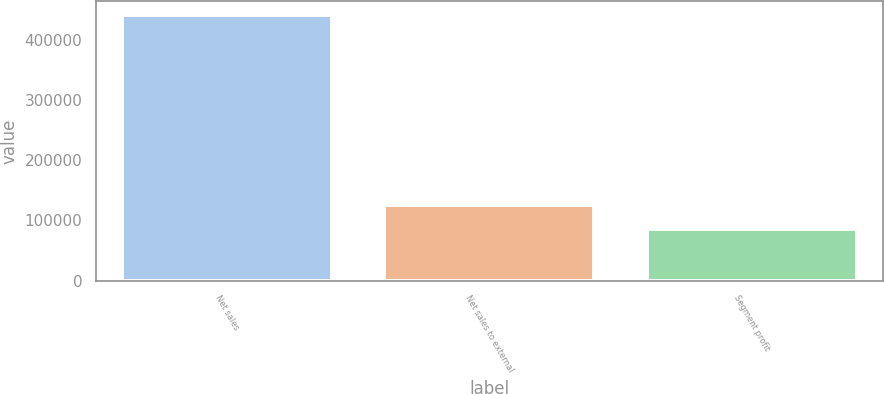Convert chart to OTSL. <chart><loc_0><loc_0><loc_500><loc_500><bar_chart><fcel>Net sales<fcel>Net sales to external<fcel>Segment profit<nl><fcel>442054<fcel>126476<fcel>86279<nl></chart> 